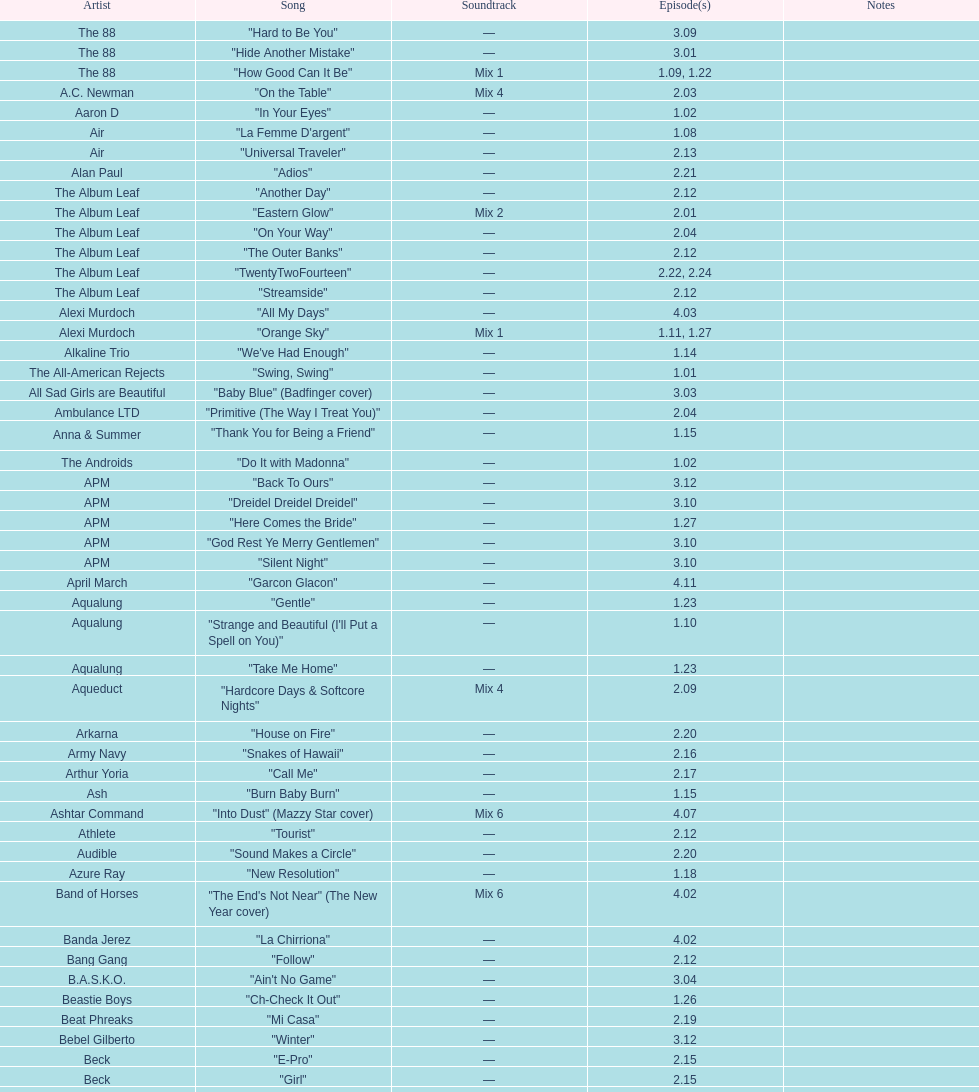"girl" and "el pro" were performed by which artist? Beck. 